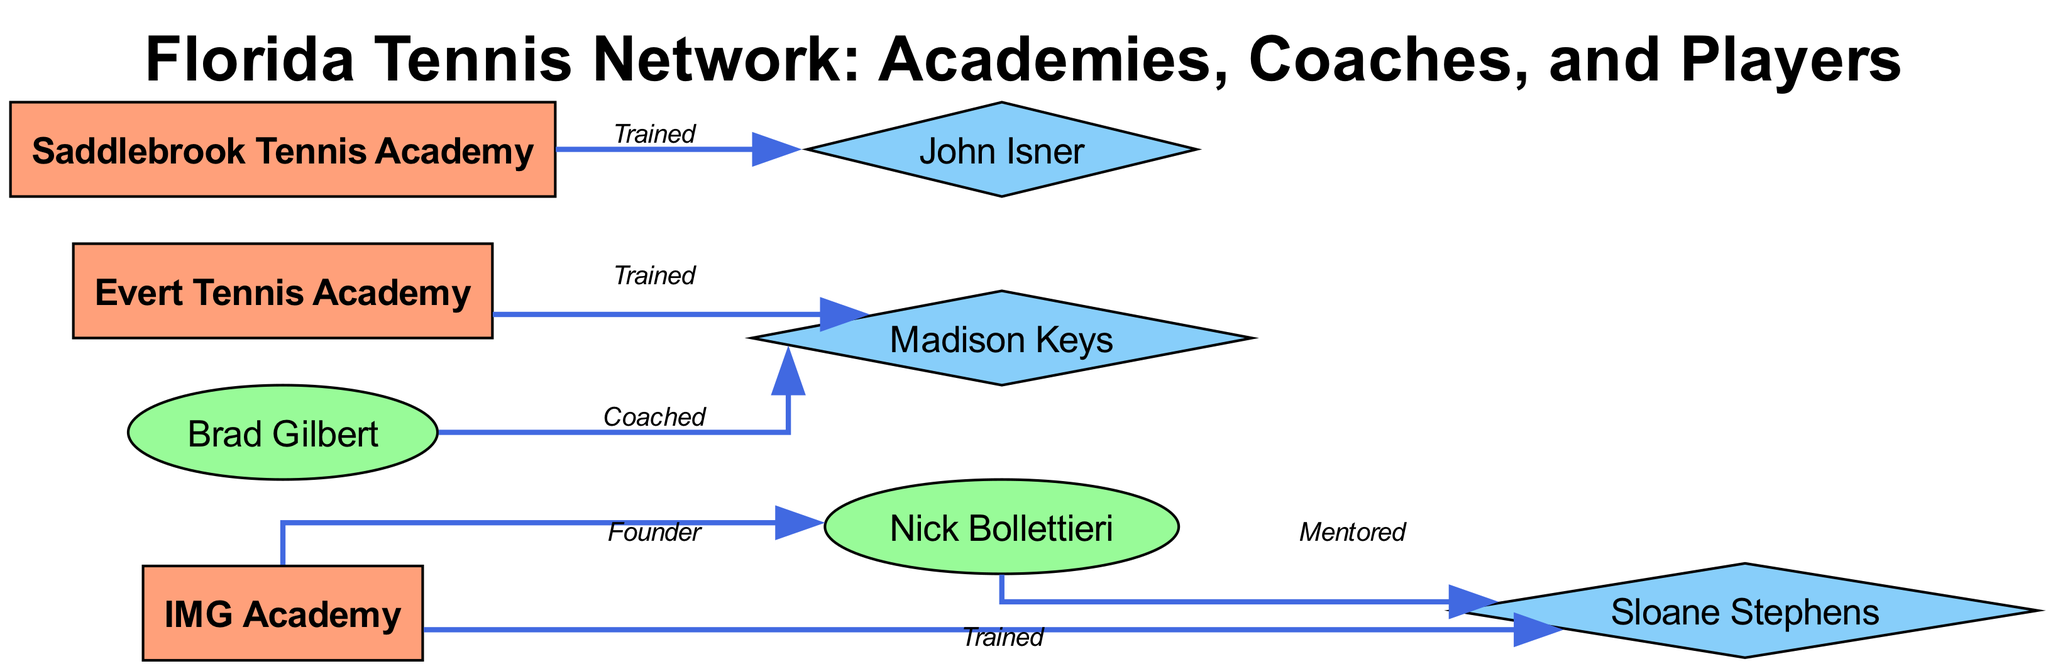What are the names of the three tennis academies depicted in this diagram? The diagram lists three tennis academies as nodes: IMG Academy, Evert Tennis Academy, and Saddlebrook Tennis Academy. By identifying the nodes marked as 'academy', we can compile their names.
Answer: IMG Academy, Evert Tennis Academy, Saddlebrook Tennis Academy Who is the coach associated with IMG Academy? The edge labeled "Founder" between IMG Academy and Nick Bollettieri indicates that Nick Bollettieri is the coach associated with IMG Academy. Therefore, by following this edge, we arrive at the answer.
Answer: Nick Bollettieri How many players are shown in the diagram? On reviewing the distinct nodes represented as players, we find Sloane Stephens, John Isner, and Madison Keys. Counting these distinct nodes gives us the number of players.
Answer: 3 Which player received training from both IMG Academy and Evert Tennis Academy? The edges from IMG Academy show Sloane Stephens trained there, and the edges from Evert Tennis Academy show Madison Keys trained there. Since no player appears trained by both academies, we conclude that no single player matches this criterion.
Answer: None Which coach is indicated as having mentored Sloane Stephens? The diagram has an edge labeled "Mentored" connecting Nick Bollettieri to Sloane Stephens. Hence, we find that Nick Bollettieri is the coach associated with this mentorship.
Answer: Nick Bollettieri What is the relationship between Brad Gilbert and Madison Keys? The diagram presents an edge labeled "Coached" connecting Brad Gilbert to Madison Keys, indicating that Brad Gilbert is the coach of Madison Keys.
Answer: Coached How many edges connect players to their respective academies? By counting the edges that directly connect player nodes to academy nodes, we examine the edges. The edges "Trained" from IMG Academy to Sloane Stephens, Evert Academy to Madison Keys, and Saddlebrook Academy to John Isner yield a total of three connections.
Answer: 3 What role does Sloane Stephens fulfill in the diagram? Upon reviewing the node labeled "Sloane Stephens," we identify her as a player, as indicated by the node's shape (diamond).
Answer: Player 